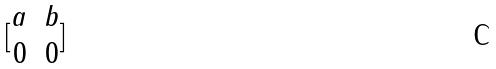<formula> <loc_0><loc_0><loc_500><loc_500>[ \begin{matrix} a & b \\ 0 & 0 \end{matrix} ]</formula> 